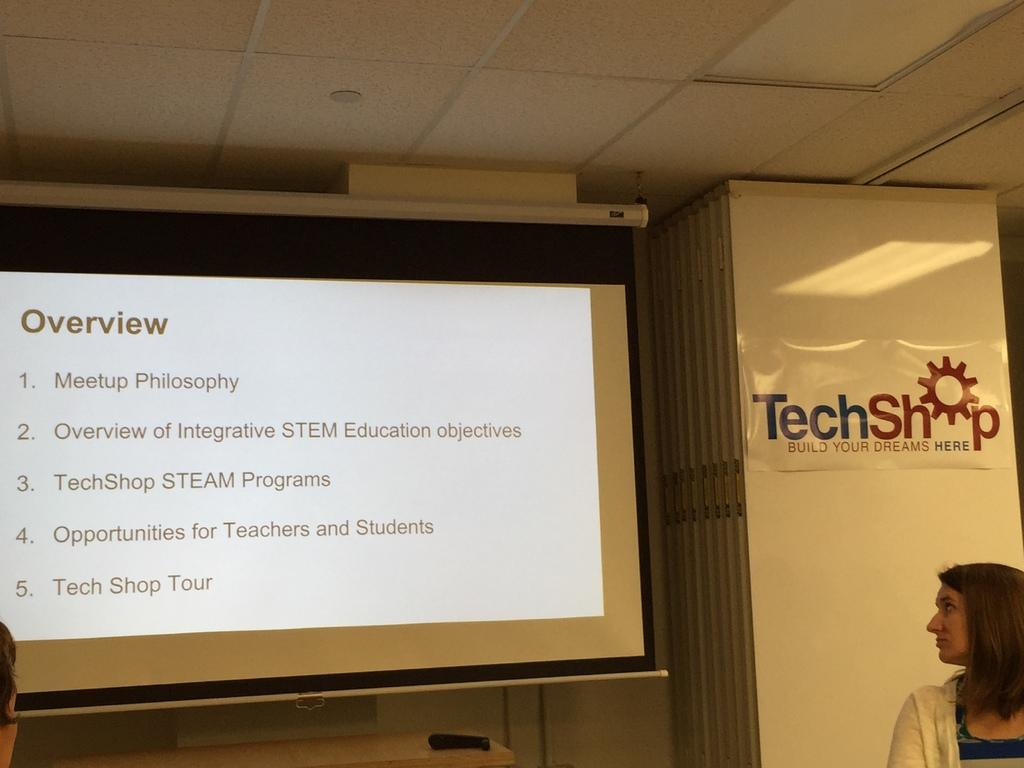What is located on the right side of the picture? There is a woman and a poster on the right side of the picture. What is on the left side of the picture? There is a projector screen and a remote on the left side of the picture. What can be seen near the ceiling in the picture? There are lights near the ceiling. How does the ghost interact with the woman in the picture? There is no ghost present in the image; it only features a woman, a poster, a projector screen, a remote, and lights near the ceiling. What is the profit margin of the zebra in the picture? There is no zebra present in the image, and therefore no profit margin can be determined. 